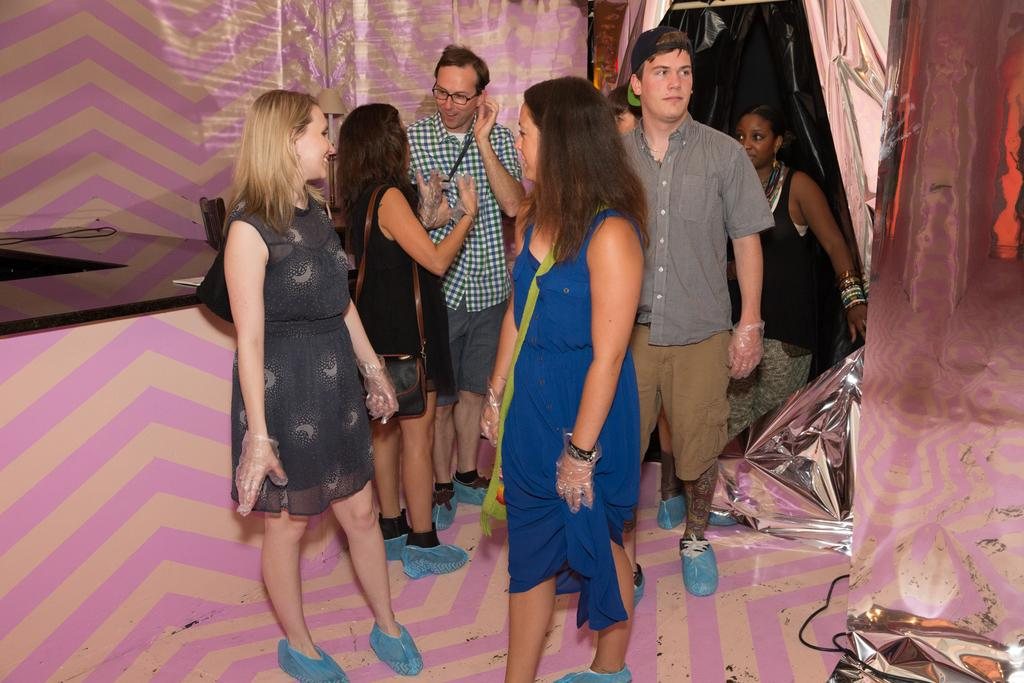What is happening in the image involving a group of people? There is a group of people standing in the image. What are the people wearing on their hands? The people are wearing gloves. What color are the shoes worn by the people in the image? The people are wearing shoes of the same color. What can be seen covering some objects in the image? There are covers in the image. Can you describe the objects visible in the image? There are some objects in the image, but their specific details are not mentioned in the provided facts. What type of mine can be seen in the background of the image? There is no mine present in the image; it features a group of people standing and wearing gloves and shoes of the same color. 